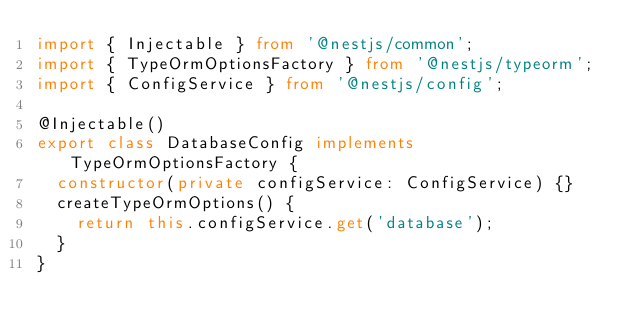<code> <loc_0><loc_0><loc_500><loc_500><_TypeScript_>import { Injectable } from '@nestjs/common';
import { TypeOrmOptionsFactory } from '@nestjs/typeorm';
import { ConfigService } from '@nestjs/config';

@Injectable()
export class DatabaseConfig implements TypeOrmOptionsFactory {
  constructor(private configService: ConfigService) {}
  createTypeOrmOptions() {
    return this.configService.get('database');
  }
}
</code> 